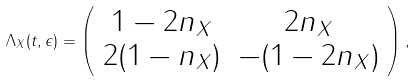<formula> <loc_0><loc_0><loc_500><loc_500>\Lambda _ { X } ( t , \epsilon ) = \left ( \begin{array} { c c } 1 - 2 n _ { X } & 2 n _ { X } \\ 2 ( 1 - n _ { X } ) & - ( 1 - 2 n _ { X } ) \end{array} \right ) ,</formula> 